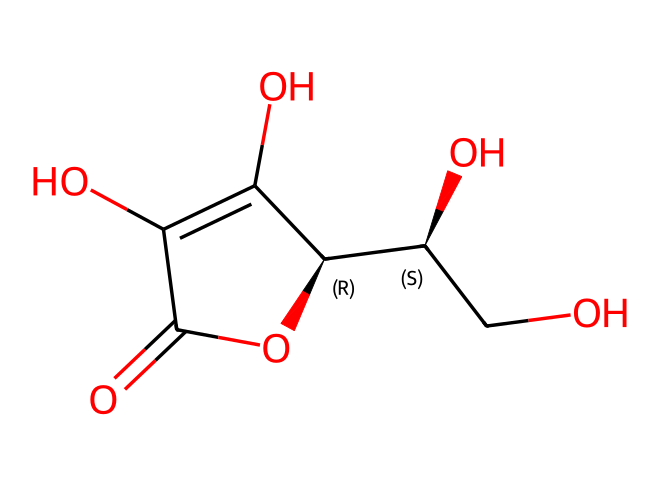What is the molecular formula of ascorbic acid? By analyzing the structure represented in the SMILES, we count the number of Carbon (C), Hydrogen (H), and Oxygen (O) atoms. The molecule has 6 Carbon atoms, 8 Hydrogen atoms, and 6 Oxygen atoms, leading to the molecular formula C6H8O6.
Answer: C6H8O6 How many rings are in the structure of ascorbic acid? Observing the SMILES representation, we can identify one cyclic structure (the ring) formed by the atoms. There is one ring made up of the carbon atoms in the structure.
Answer: 1 Is ascorbic acid a carbohydrate? Ascorbic acid contains a structure featuring multiple hydroxyl groups (-OH) and oxygen, but it does not fit the definition of carbohydrates due to its different arrangement and functional groups.
Answer: No What is the primary functional group in ascorbic acid? The structure shows several hydroxyl (-OH) groups prominently, which are the primary functional groups present throughout the molecule, contributing to its chemical properties.
Answer: Hydroxyl group Does ascorbic acid enhance nutrient content in GM fruits? Ascorbic acid is known to play a role in enhancing nutrient content, particularly in fruits, as it is a vital vitamin that contributes to their overall nutritional value.
Answer: Yes What does the presence of the double bond in ascorbic acid indicate? The double bond within the chemical structure indicates unsaturation, which can influence its reactivity and stability, making vitamins easy to oxidize and degrade if not properly stored.
Answer: Unsaturation What type of food additive is ascorbic acid classified as? Ascorbic acid is utilized as an antioxidant in food preservation, helping to maintain flavor, color, and nutritional quality in food products, thus classifying it as a food additive.
Answer: Antioxidant 